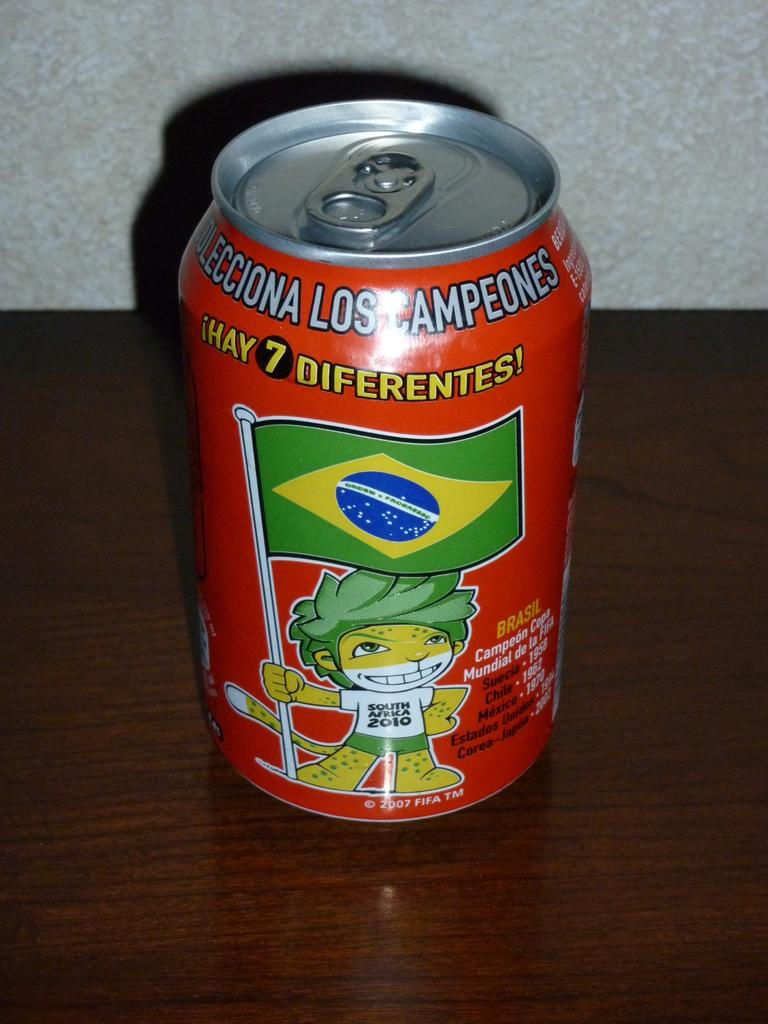Provide a one-sentence caption for the provided image. A can from Brazil that is red and says 7 diferntes!. 